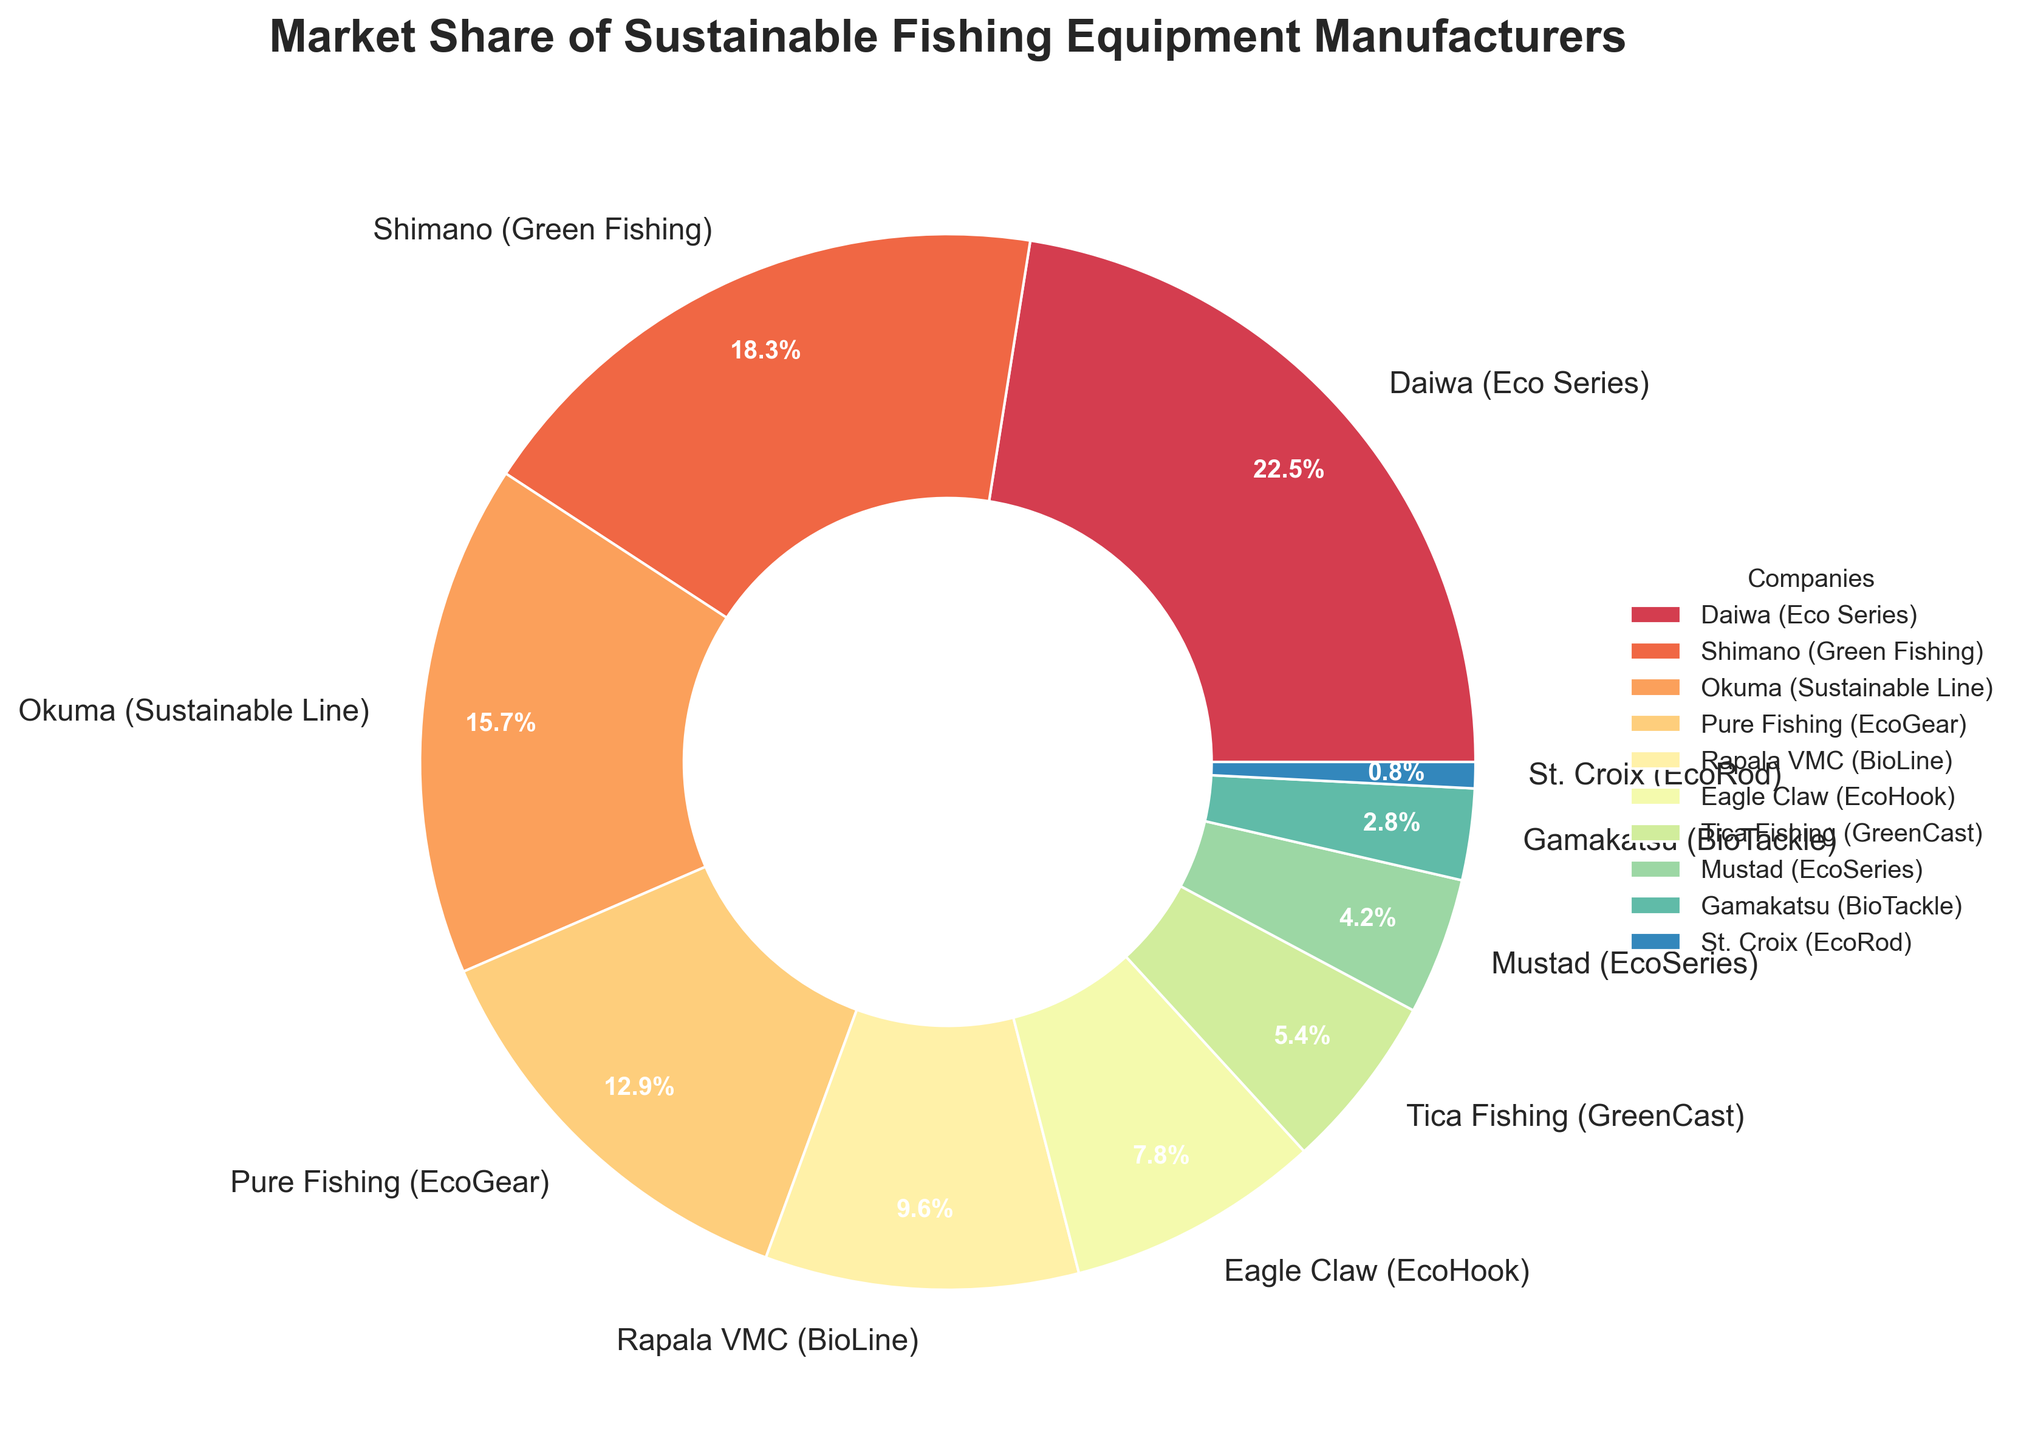What is the market share of the leading company, and which company is it? The leading company is the one with the highest market share. From the figure, Daiwa (Eco Series) has the largest segment. The market share for Daiwa (Eco Series) is 22.5%.
Answer: 22.5%, Daiwa (Eco Series) What is the combined market share of Daiwa (Eco Series) and Shimano (Green Fishing)? To find the combined market share of these two companies, simply sum their individual market shares. Daiwa (Eco Series) has 22.5%, and Shimano (Green Fishing) has 18.3%. So the combined market share is 22.5% + 18.3% = 40.8%.
Answer: 40.8% Which company has the smallest market share, and what is the value? The company with the smallest market share will have the smallest segment in the pie chart. St. Croix (EcoRod) has the smallest segment, with a market share of 0.8%.
Answer: St. Croix (EcoRod), 0.8% How much larger is Daiwa (Eco Series)'s market share compared to St. Croix (EcoRod)? The difference in market share between Daiwa (Eco Series) and St. Croix (EcoRod) is calculated by subtracting St. Croix's market share from Daiwa's market share. So, 22.5% - 0.8% = 21.7%.
Answer: 21.7% What is the average market share of all the companies besides Daiwa (Eco Series)? First, sum the market shares of all the companies except Daiwa: Shimano (18.3%) + Okuma (15.7%) + Pure Fishing (12.9%) + Rapala VMC (9.6%) + Eagle Claw (7.8%) + Tica Fishing (5.4%) + Mustad (4.2%) + Gamakatsu (2.8%) + St. Croix (0.8%). The total is 77.5%. Then, divide by the 9 companies to get the average: 77.5% / 9 ≈ 8.61%.
Answer: 8.61% Which companies have a market share greater than 10%? By looking at the pie chart, the companies with segments representing more than 10% are Daiwa (22.5%), Shimano (18.3%), Okuma (15.7%), and Pure Fishing (12.9%).
Answer: Daiwa, Shimano, Okuma, Pure Fishing How does Rapala VMC's market share compare to Eagle Claw's market share? Rapala VMC has a market share of 9.6%, while Eagle Claw has a market share of 7.8%. By comparison, Rapala VMC's market share is larger than Eagle Claw's by 9.6% - 7.8% = 1.8%.
Answer: Rapala VMC is 1.8% larger What is the total market share of companies with a market share less than 5%? Sum the market shares of Tica Fishing (5.4%), Mustad (4.2%), Gamakatsu (2.8%), and St. Croix (0.8%), as they all have segments less than 5%. So 5.4% + 4.2% + 2.8% + 0.8% = 13.2%.
Answer: 13.2% Which companies have market shares marked by colors closer to the middle of the spectral range? By observing the colors, the mid-range colors are likely to be in the central hues such as green or yellow. The market shares associated with these colors can typically follow the order of appearance in the legend. Pure Fishing (EcoGear) (green) and Rapala VMC (BioLine) (yellow) are closer to the middle spectral colors.
Answer: Pure Fishing, Rapala VMC 